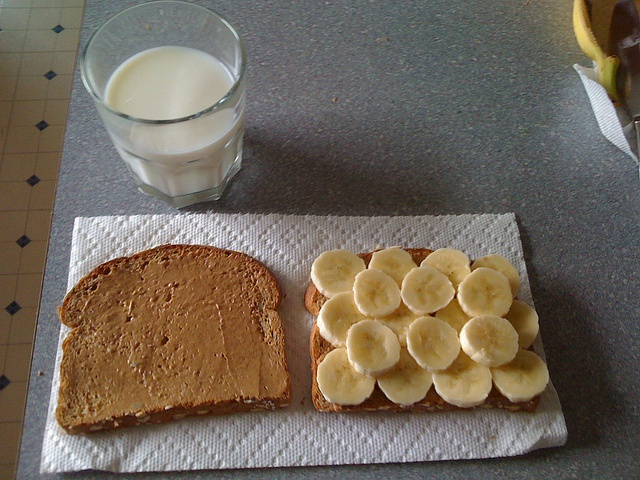Describe the objects in this image and their specific colors. I can see dining table in gray, darkgray, black, and olive tones, sandwich in gray, brown, and maroon tones, sandwich in gray, tan, olive, and maroon tones, cup in gray and darkgray tones, and banana in gray, tan, olive, and maroon tones in this image. 